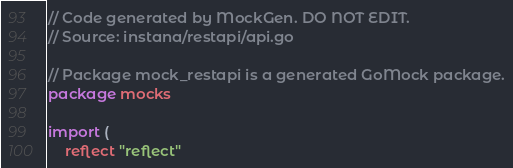Convert code to text. <code><loc_0><loc_0><loc_500><loc_500><_Go_>// Code generated by MockGen. DO NOT EDIT.
// Source: instana/restapi/api.go

// Package mock_restapi is a generated GoMock package.
package mocks

import (
	reflect "reflect"
</code> 